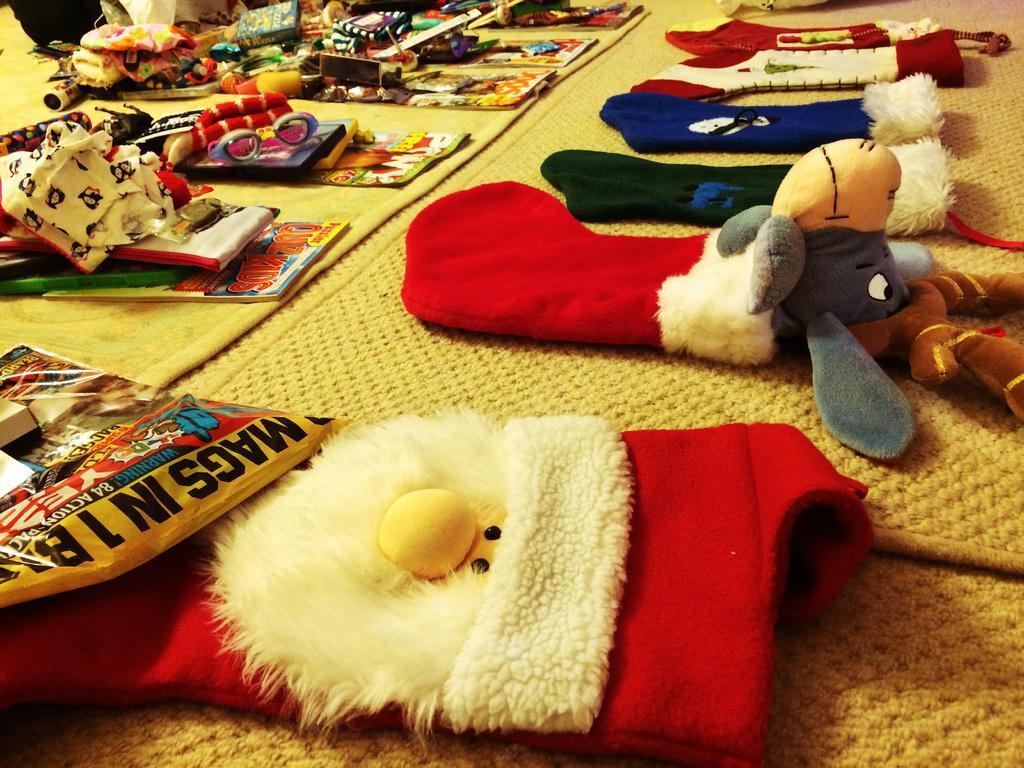In one or two sentences, can you explain what this image depicts? This picture shows few christmas socks and a soft toy. We see few clothes, Gifts on the floor and we see carpets on the floor. 